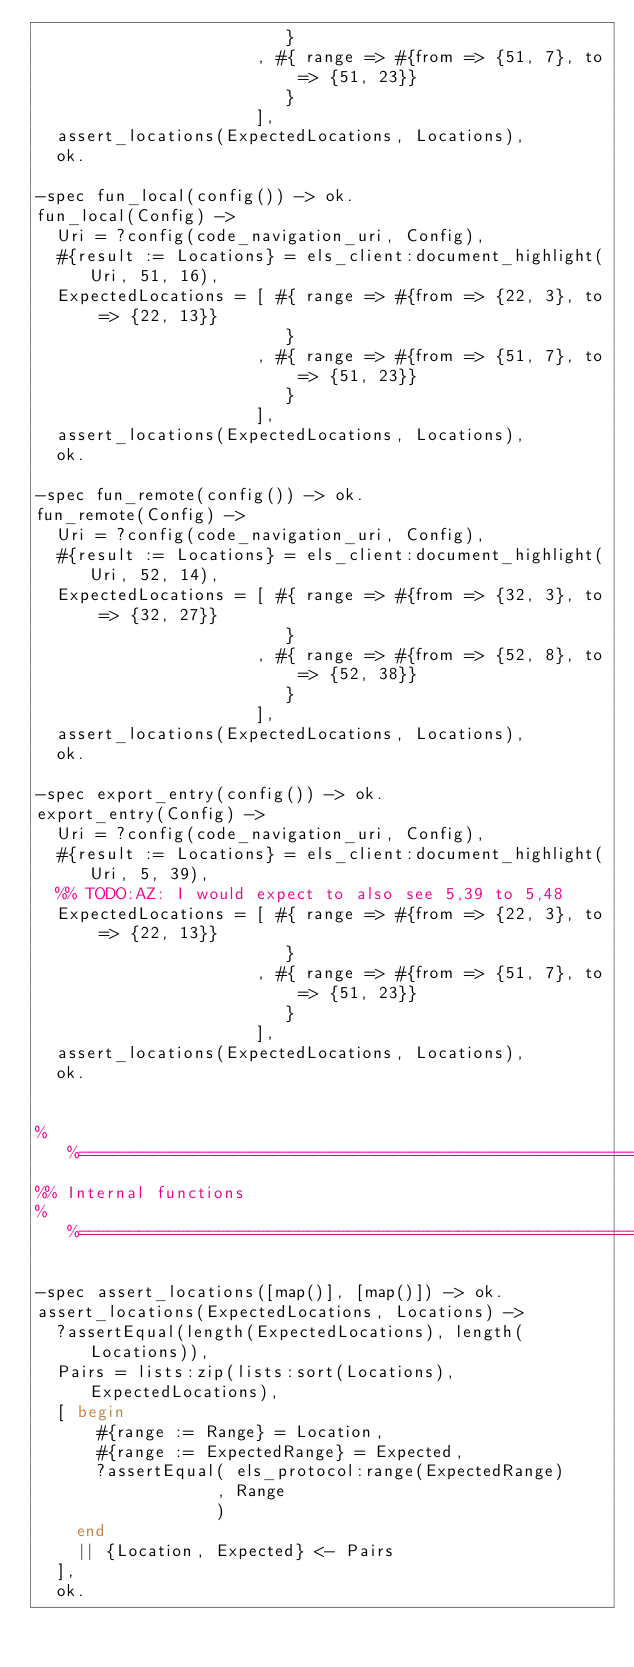Convert code to text. <code><loc_0><loc_0><loc_500><loc_500><_Erlang_>                         }
                      , #{ range => #{from => {51, 7}, to => {51, 23}}
                         }
                      ],
  assert_locations(ExpectedLocations, Locations),
  ok.

-spec fun_local(config()) -> ok.
fun_local(Config) ->
  Uri = ?config(code_navigation_uri, Config),
  #{result := Locations} = els_client:document_highlight(Uri, 51, 16),
  ExpectedLocations = [ #{ range => #{from => {22, 3}, to => {22, 13}}
                         }
                      , #{ range => #{from => {51, 7}, to => {51, 23}}
                         }
                      ],
  assert_locations(ExpectedLocations, Locations),
  ok.

-spec fun_remote(config()) -> ok.
fun_remote(Config) ->
  Uri = ?config(code_navigation_uri, Config),
  #{result := Locations} = els_client:document_highlight(Uri, 52, 14),
  ExpectedLocations = [ #{ range => #{from => {32, 3}, to => {32, 27}}
                         }
                      , #{ range => #{from => {52, 8}, to => {52, 38}}
                         }
                      ],
  assert_locations(ExpectedLocations, Locations),
  ok.

-spec export_entry(config()) -> ok.
export_entry(Config) ->
  Uri = ?config(code_navigation_uri, Config),
  #{result := Locations} = els_client:document_highlight(Uri, 5, 39),
  %% TODO:AZ: I would expect to also see 5,39 to 5,48
  ExpectedLocations = [ #{ range => #{from => {22, 3}, to => {22, 13}}
                         }
                      , #{ range => #{from => {51, 7}, to => {51, 23}}
                         }
                      ],
  assert_locations(ExpectedLocations, Locations),
  ok.


%%==============================================================================
%% Internal functions
%%==============================================================================

-spec assert_locations([map()], [map()]) -> ok.
assert_locations(ExpectedLocations, Locations) ->
  ?assertEqual(length(ExpectedLocations), length(Locations)),
  Pairs = lists:zip(lists:sort(Locations), ExpectedLocations),
  [ begin
      #{range := Range} = Location,
      #{range := ExpectedRange} = Expected,
      ?assertEqual( els_protocol:range(ExpectedRange)
                  , Range
                  )
    end
    || {Location, Expected} <- Pairs
  ],
  ok.
</code> 